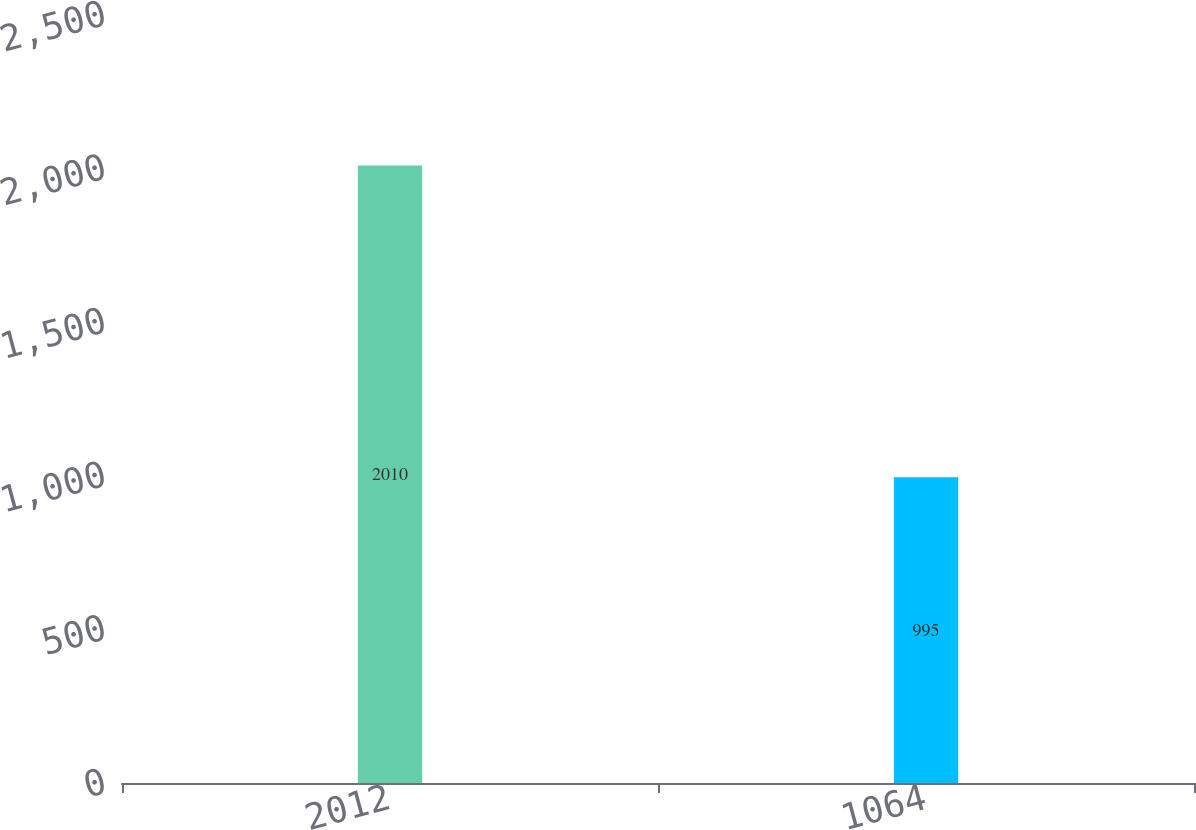<chart> <loc_0><loc_0><loc_500><loc_500><bar_chart><fcel>2012<fcel>1064<nl><fcel>2010<fcel>995<nl></chart> 